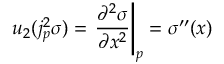Convert formula to latex. <formula><loc_0><loc_0><loc_500><loc_500>u _ { 2 } ( j _ { p } ^ { 2 } \sigma ) = { \frac { \partial ^ { 2 } \sigma } { \partial x ^ { 2 } } } \right | _ { p } = \sigma ^ { \prime \prime } ( x )</formula> 